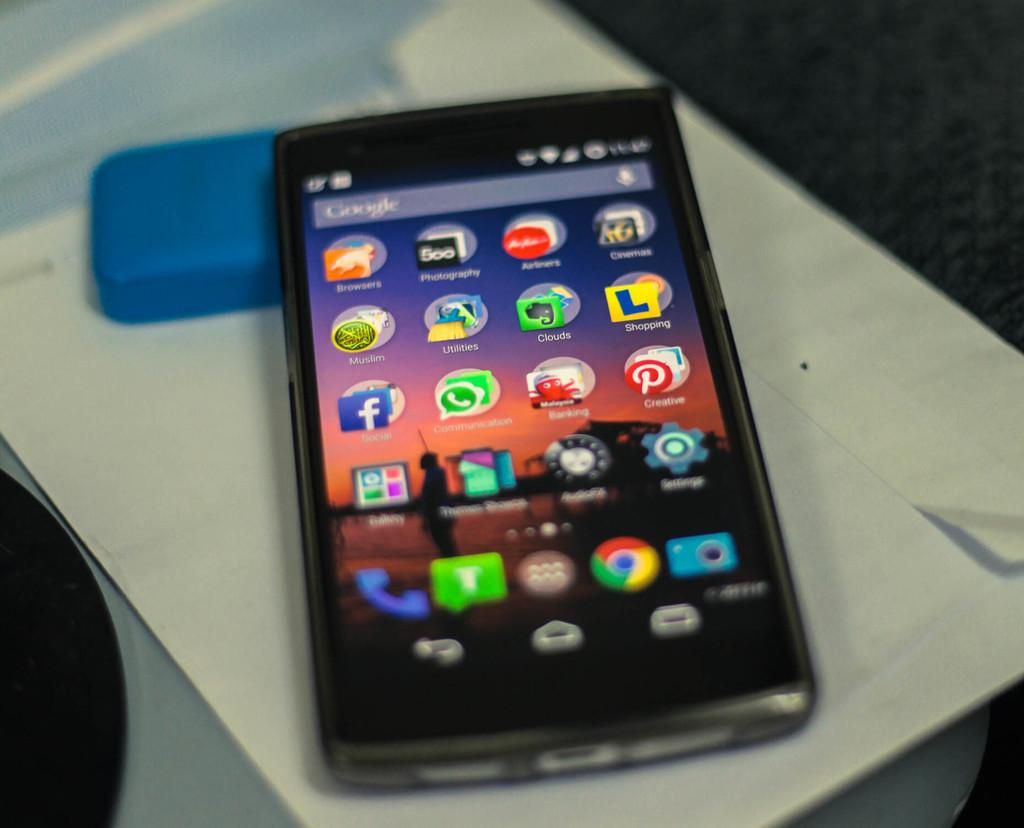<image>
Give a short and clear explanation of the subsequent image. A cell phone screen is turned on to show several apps, including whatsapp, pinterest and facebook. 